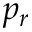Convert formula to latex. <formula><loc_0><loc_0><loc_500><loc_500>p _ { r }</formula> 